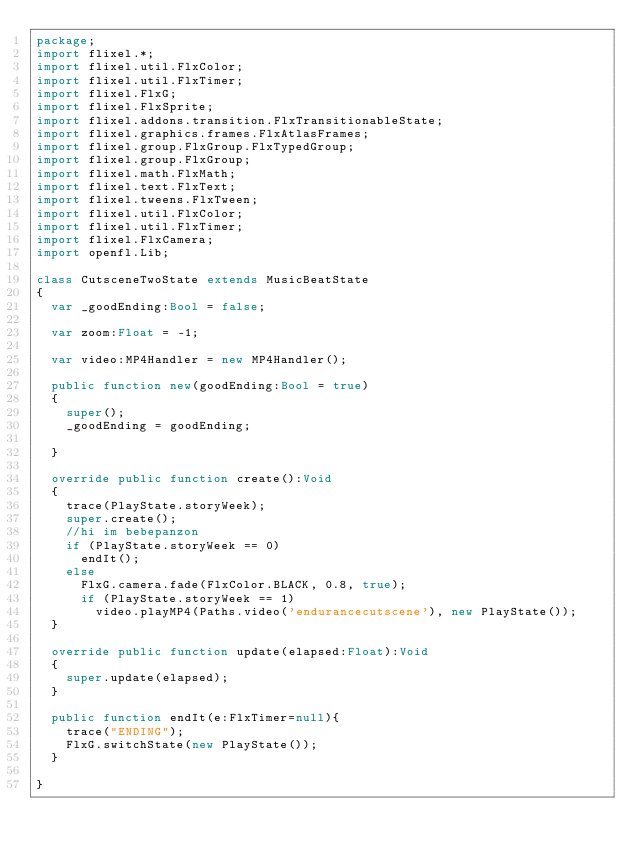<code> <loc_0><loc_0><loc_500><loc_500><_Haxe_>package;
import flixel.*;
import flixel.util.FlxColor;
import flixel.util.FlxTimer;
import flixel.FlxG;
import flixel.FlxSprite;
import flixel.addons.transition.FlxTransitionableState;
import flixel.graphics.frames.FlxAtlasFrames;
import flixel.group.FlxGroup.FlxTypedGroup;
import flixel.group.FlxGroup;
import flixel.math.FlxMath;
import flixel.text.FlxText;
import flixel.tweens.FlxTween;
import flixel.util.FlxColor;
import flixel.util.FlxTimer;
import flixel.FlxCamera;
import openfl.Lib;

class CutsceneTwoState extends MusicBeatState
{
	var _goodEnding:Bool = false;

	var zoom:Float = -1;

	var video:MP4Handler = new MP4Handler();
	
	public function new(goodEnding:Bool = true) 
	{
		super();
		_goodEnding = goodEnding;
		
	}
	
	override public function create():Void 
	{
		trace(PlayState.storyWeek);
		super.create();	
		//hi im bebepanzon
		if (PlayState.storyWeek == 0)
			endIt();
		else
			FlxG.camera.fade(FlxColor.BLACK, 0.8, true);
			if (PlayState.storyWeek == 1)
				video.playMP4(Paths.video('endurancecutscene'), new PlayState());
	}
	
	override public function update(elapsed:Float):Void 
	{
		super.update(elapsed);
	}
	
	public function endIt(e:FlxTimer=null){
		trace("ENDING");
		FlxG.switchState(new PlayState());
	}
	
}</code> 